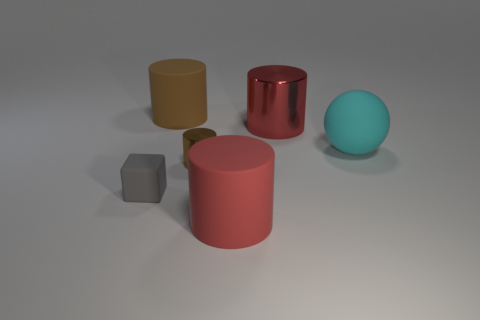There is a shiny cylinder that is to the left of the large matte cylinder that is in front of the big brown rubber object; what is its size?
Provide a succinct answer. Small. How many rubber things have the same color as the tiny metal cylinder?
Provide a succinct answer. 1. There is a metallic thing on the right side of the large matte cylinder in front of the large cyan object; what shape is it?
Offer a terse response. Cylinder. What number of tiny green balls are made of the same material as the tiny block?
Give a very brief answer. 0. There is a big cylinder that is right of the red matte object; what is it made of?
Your answer should be very brief. Metal. There is a matte thing that is to the left of the brown cylinder on the left side of the brown metal object that is on the right side of the cube; what is its shape?
Your answer should be very brief. Cube. Does the metallic object in front of the big metal object have the same color as the tiny thing that is to the left of the small metallic cylinder?
Give a very brief answer. No. Is the number of big metallic cylinders on the right side of the big red metallic cylinder less than the number of red cylinders that are left of the big cyan matte thing?
Keep it short and to the point. Yes. Is there any other thing that has the same shape as the cyan matte thing?
Ensure brevity in your answer.  No. What color is the other metallic thing that is the same shape as the small brown thing?
Your answer should be very brief. Red. 